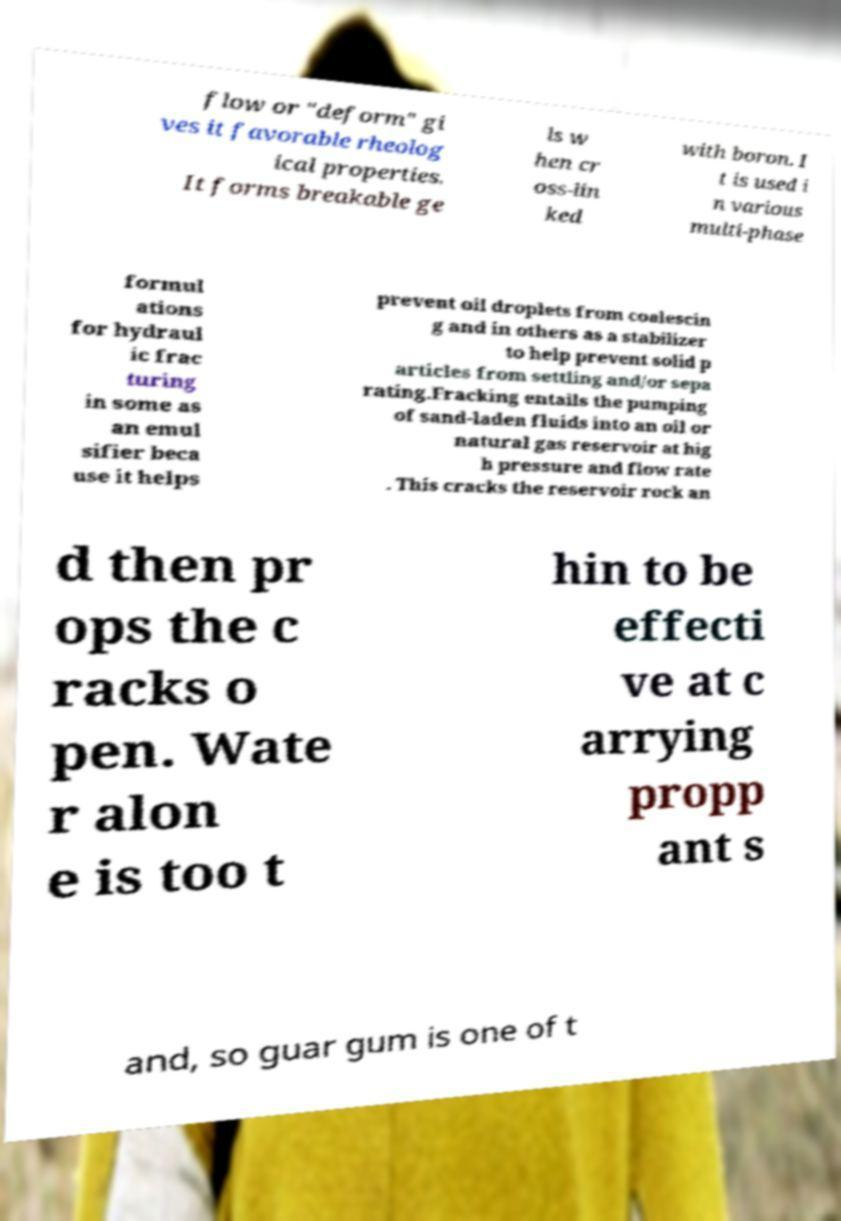There's text embedded in this image that I need extracted. Can you transcribe it verbatim? flow or "deform" gi ves it favorable rheolog ical properties. It forms breakable ge ls w hen cr oss-lin ked with boron. I t is used i n various multi-phase formul ations for hydraul ic frac turing in some as an emul sifier beca use it helps prevent oil droplets from coalescin g and in others as a stabilizer to help prevent solid p articles from settling and/or sepa rating.Fracking entails the pumping of sand-laden fluids into an oil or natural gas reservoir at hig h pressure and flow rate . This cracks the reservoir rock an d then pr ops the c racks o pen. Wate r alon e is too t hin to be effecti ve at c arrying propp ant s and, so guar gum is one of t 